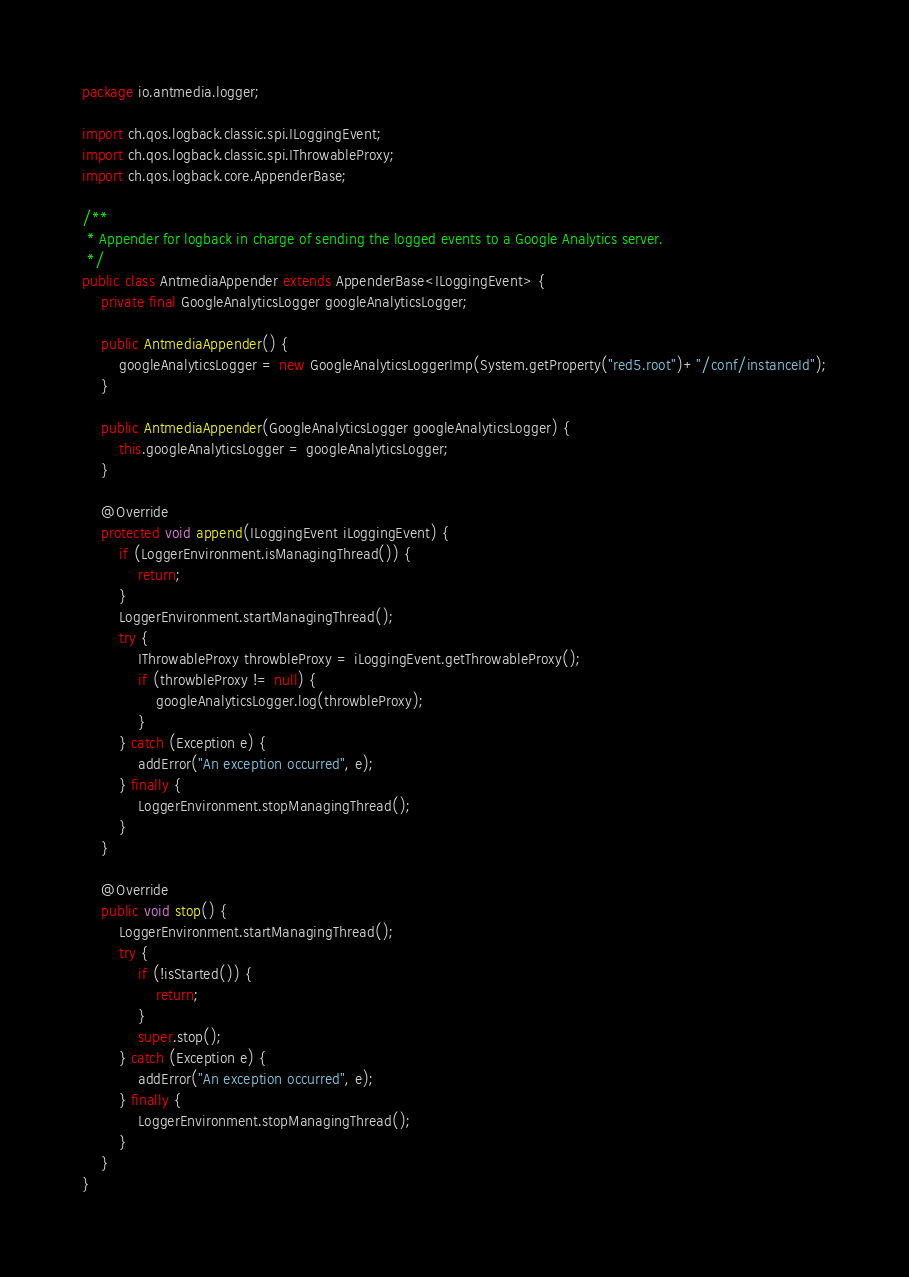Convert code to text. <code><loc_0><loc_0><loc_500><loc_500><_Java_>package io.antmedia.logger;

import ch.qos.logback.classic.spi.ILoggingEvent;
import ch.qos.logback.classic.spi.IThrowableProxy;
import ch.qos.logback.core.AppenderBase;

/**
 * Appender for logback in charge of sending the logged events to a Google Analytics server.
 */
public class AntmediaAppender extends AppenderBase<ILoggingEvent> {
    private final GoogleAnalyticsLogger googleAnalyticsLogger;

    public AntmediaAppender() {
        googleAnalyticsLogger = new GoogleAnalyticsLoggerImp(System.getProperty("red5.root")+"/conf/instanceId");
    }

    public AntmediaAppender(GoogleAnalyticsLogger googleAnalyticsLogger) {
        this.googleAnalyticsLogger = googleAnalyticsLogger;
    }

    @Override
    protected void append(ILoggingEvent iLoggingEvent) {
        if (LoggerEnvironment.isManagingThread()) {
            return;
        }
        LoggerEnvironment.startManagingThread();
        try {
            IThrowableProxy throwbleProxy = iLoggingEvent.getThrowableProxy();
            if (throwbleProxy != null) {
                googleAnalyticsLogger.log(throwbleProxy);
            }
        } catch (Exception e) {
            addError("An exception occurred", e);
        } finally {
            LoggerEnvironment.stopManagingThread();
        }
    }

    @Override
    public void stop() {
        LoggerEnvironment.startManagingThread();
        try {
            if (!isStarted()) {
                return;
            }
            super.stop();
        } catch (Exception e) {
            addError("An exception occurred", e);
        } finally {
            LoggerEnvironment.stopManagingThread();
        }
    }
}</code> 